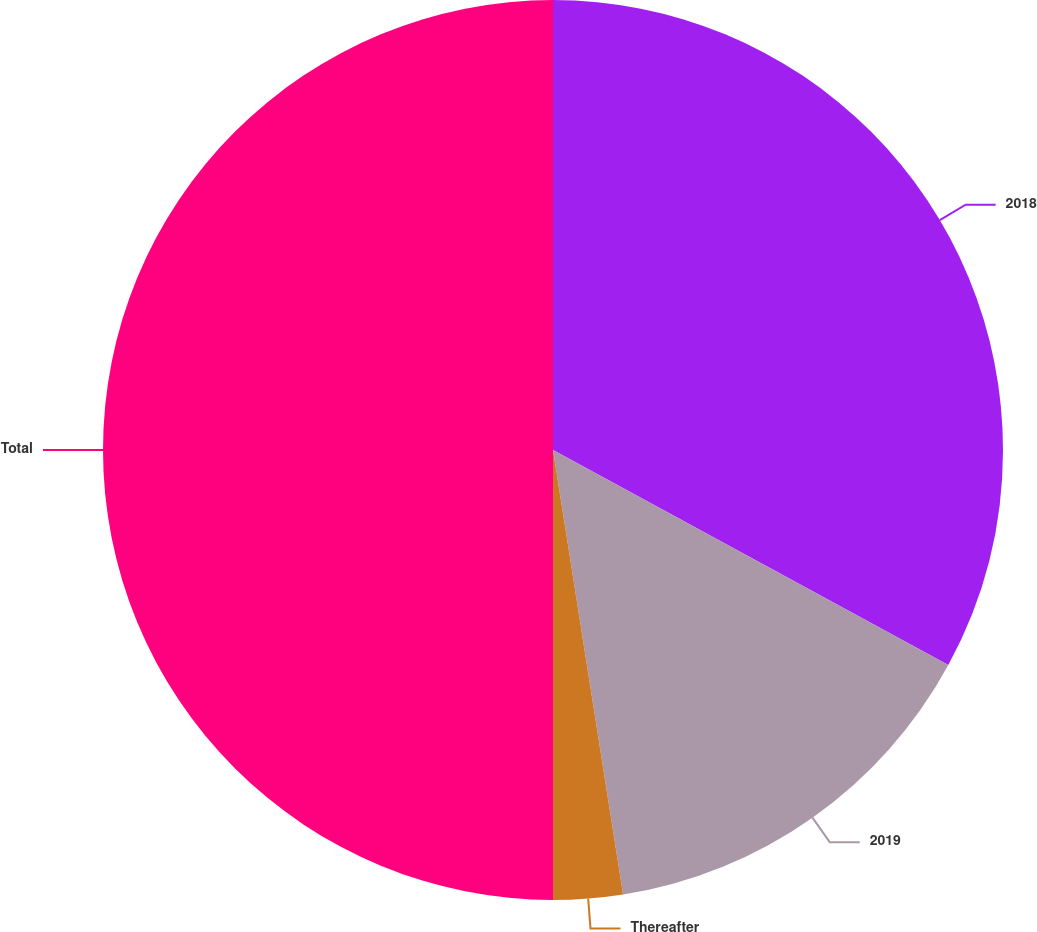<chart> <loc_0><loc_0><loc_500><loc_500><pie_chart><fcel>2018<fcel>2019<fcel>Thereafter<fcel>Total<nl><fcel>32.93%<fcel>14.58%<fcel>2.49%<fcel>50.0%<nl></chart> 